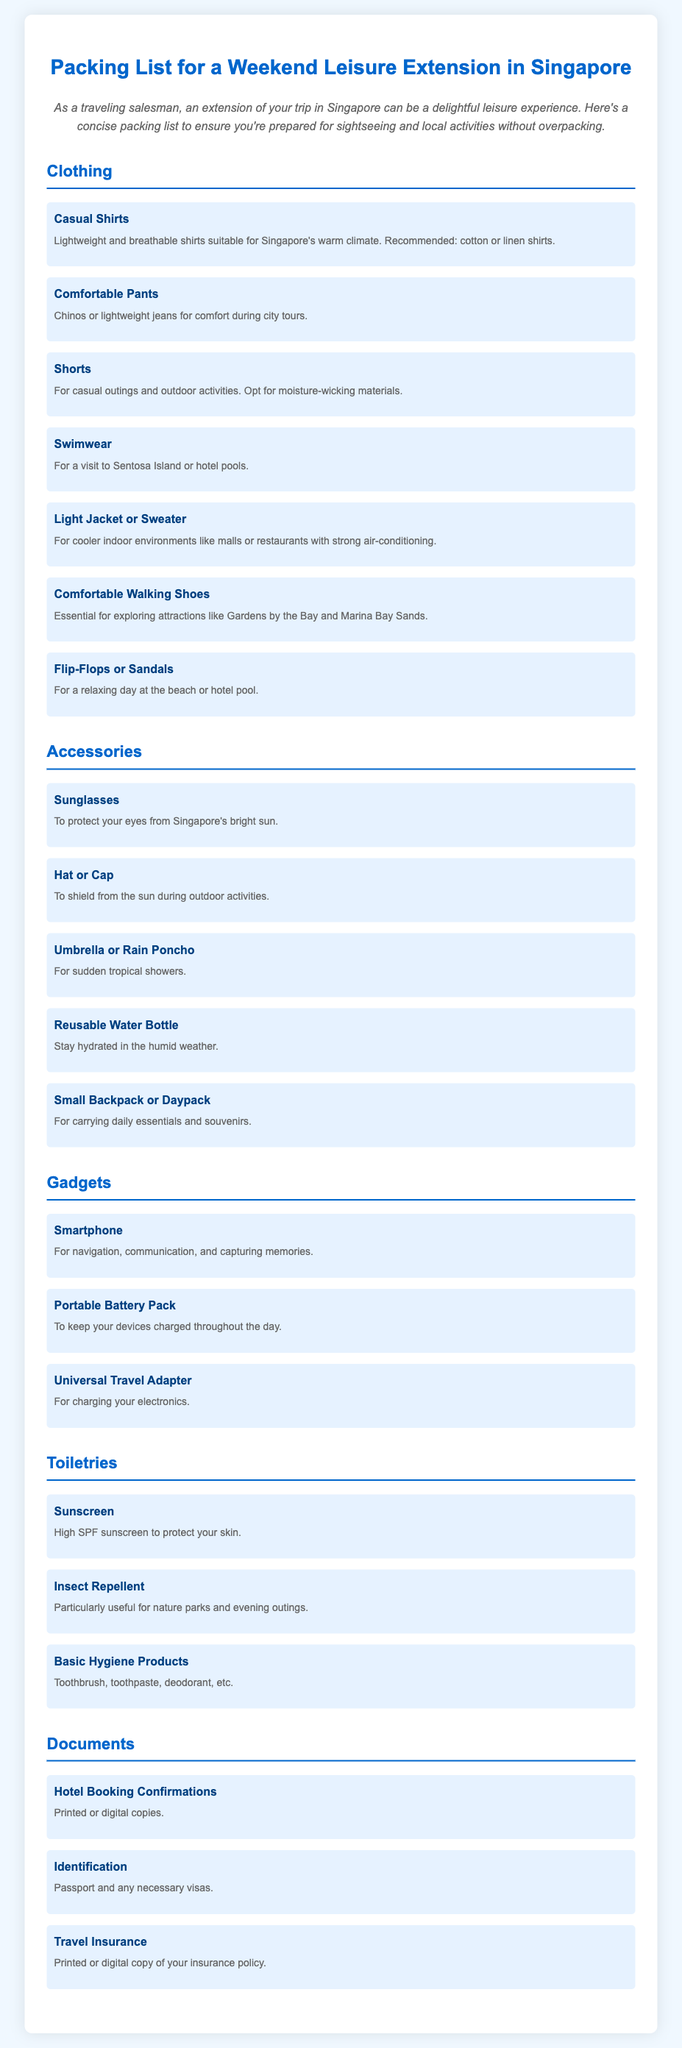what items are recommended for outdoor activities? The document lists "Shorts" and "Umbrella or Rain Poncho" as recommended for outdoor activities.
Answer: Shorts, Umbrella or Rain Poncho which clothing item is essential for city tours? The document specifies "Comfortable Walking Shoes" as essential for exploring attractions.
Answer: Comfortable Walking Shoes how many types of sunglasses are mentioned? The document mentions only one type of sunglasses as an accessory.
Answer: One what type of sunscreen is advised? The document recommends using "High SPF sunscreen" to protect your skin.
Answer: High SPF sunscreen what documents should be kept handy while traveling? The document lists "Hotel Booking Confirmations," "Identification," and "Travel Insurance."
Answer: Hotel Booking Confirmations, Identification, Travel Insurance why would you need a portable battery pack? The document states that a portable battery pack is needed to keep your devices charged throughout the day.
Answer: To keep devices charged which type of pants are suggested for comfort? The document recommends "Chinos or lightweight jeans" for comfort during city tours.
Answer: Chinos or lightweight jeans is insect repellent mentioned in the toiletries section? Yes, the document includes "Insect Repellent" in the toiletries section.
Answer: Yes 